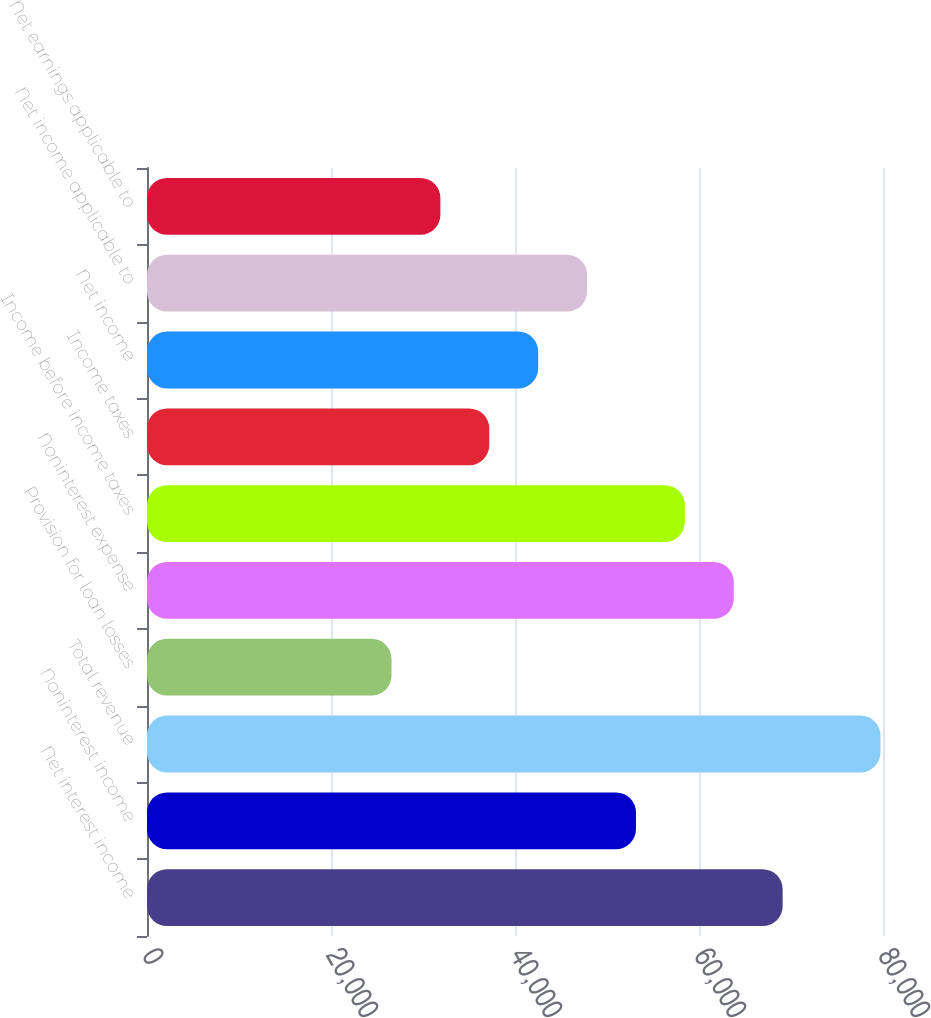<chart> <loc_0><loc_0><loc_500><loc_500><bar_chart><fcel>Net interest income<fcel>Noninterest income<fcel>Total revenue<fcel>Provision for loan losses<fcel>Noninterest expense<fcel>Income before income taxes<fcel>Income taxes<fcel>Net income<fcel>Net income applicable to<fcel>Net earnings applicable to<nl><fcel>69093.7<fcel>53149<fcel>79723.5<fcel>26574.5<fcel>63778.8<fcel>58463.9<fcel>37204.3<fcel>42519.2<fcel>47834.1<fcel>31889.4<nl></chart> 